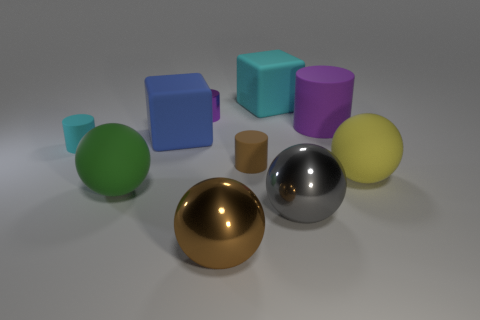Subtract all cyan cylinders. How many cylinders are left? 3 Subtract all cyan cubes. How many cubes are left? 1 Subtract all yellow balls. How many purple cylinders are left? 2 Subtract 2 balls. How many balls are left? 2 Subtract all cylinders. How many objects are left? 6 Subtract all green spheres. Subtract all cyan cylinders. How many spheres are left? 3 Subtract all big brown matte blocks. Subtract all tiny things. How many objects are left? 7 Add 7 big matte spheres. How many big matte spheres are left? 9 Add 7 cyan cylinders. How many cyan cylinders exist? 8 Subtract 0 red cubes. How many objects are left? 10 